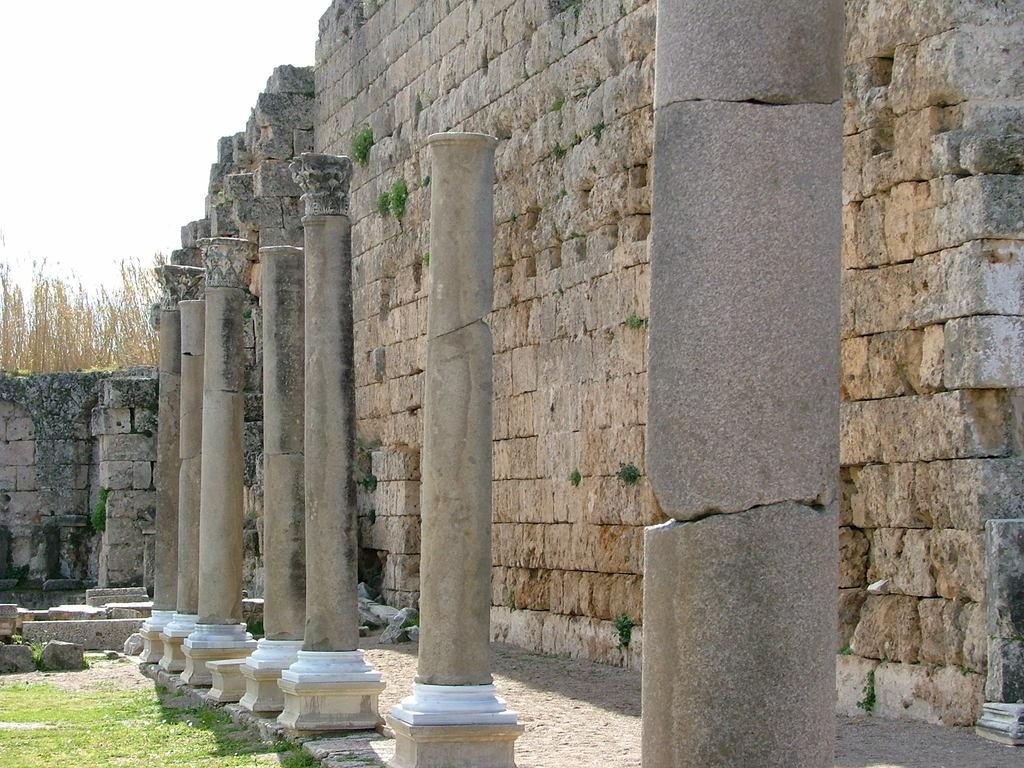What architectural feature can be seen in the image? There are column pillars in the image. What type of structure might these column pillars be a part of? The column pillars could be part of a building or a structure with walls. What can be seen in the background of the image? There are trees and grass in the image. What type of material is present in the image? There are stones in the image. What is visible in the sky in the image? The sky is visible in the image. What is the name of the person standing next to the trees in the image? There are no people visible in the image, so it is not possible to determine the name of a person standing next to the trees. 